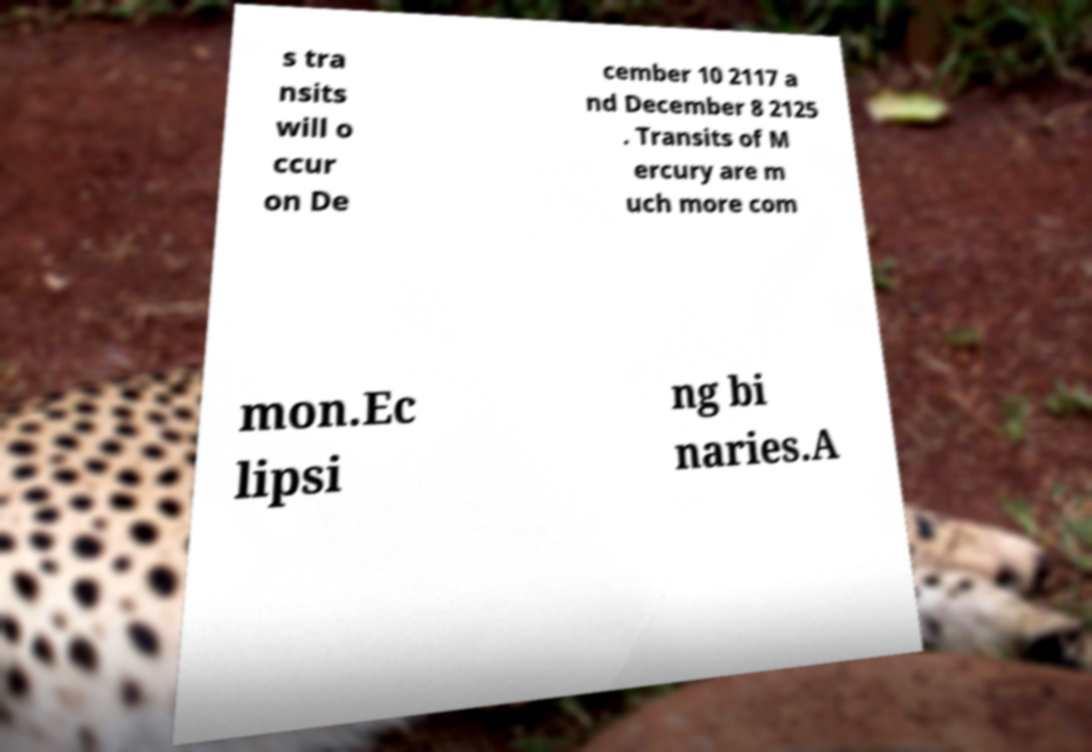For documentation purposes, I need the text within this image transcribed. Could you provide that? s tra nsits will o ccur on De cember 10 2117 a nd December 8 2125 . Transits of M ercury are m uch more com mon.Ec lipsi ng bi naries.A 